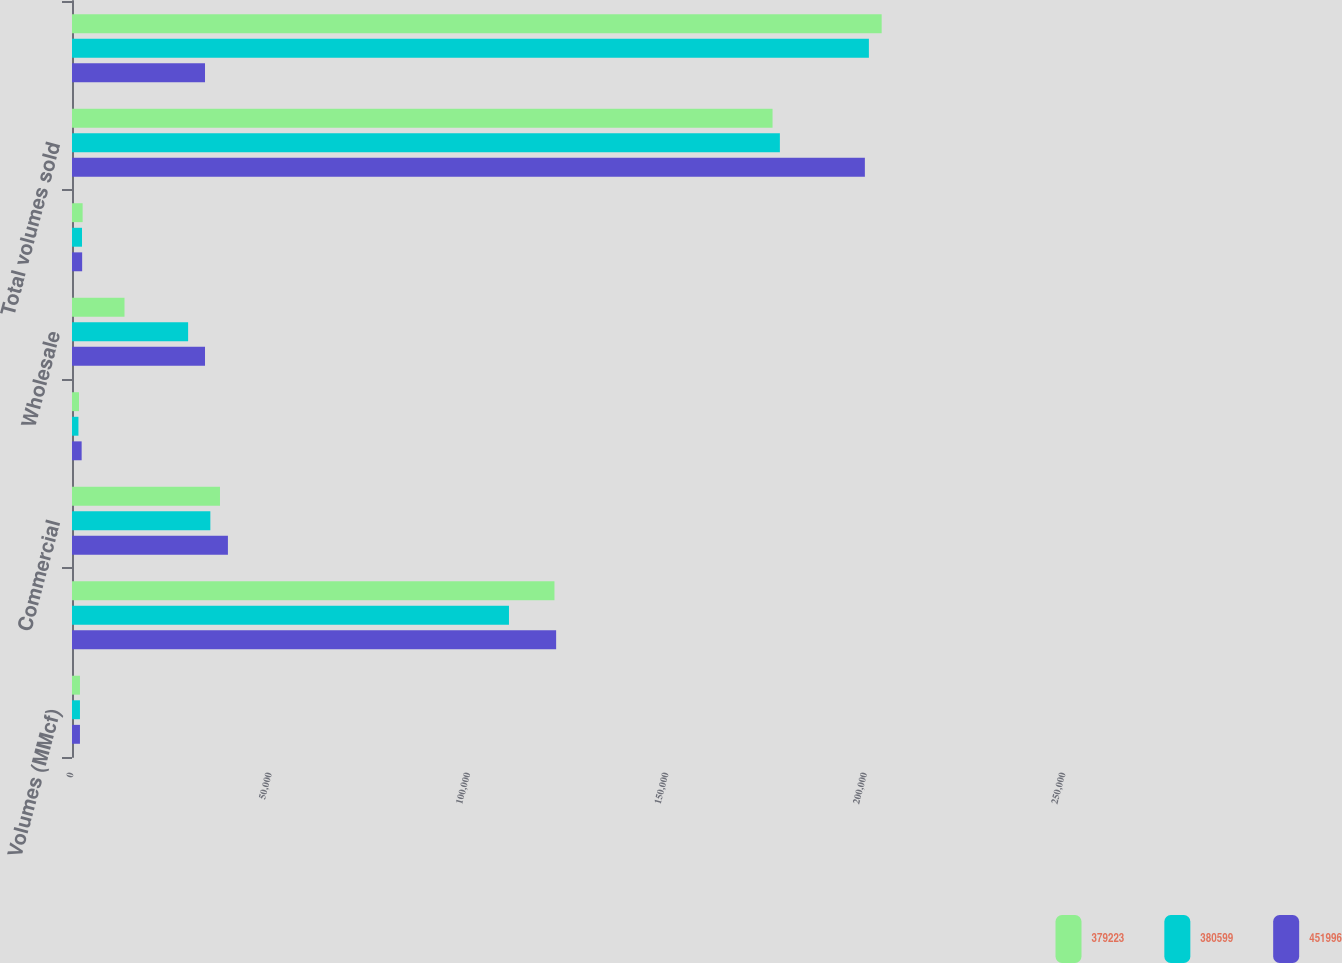<chart> <loc_0><loc_0><loc_500><loc_500><stacked_bar_chart><ecel><fcel>Volumes (MMcf)<fcel>Residential<fcel>Commercial<fcel>Industrial<fcel>Wholesale<fcel>Public Authority<fcel>Total volumes sold<fcel>Transportation<nl><fcel>379223<fcel>2007<fcel>121587<fcel>37295<fcel>1758<fcel>13231<fcel>2679<fcel>176550<fcel>204049<nl><fcel>380599<fcel>2006<fcel>110123<fcel>34865<fcel>1624<fcel>29263<fcel>2520<fcel>178395<fcel>200828<nl><fcel>451996<fcel>2005<fcel>122010<fcel>39294<fcel>2432<fcel>33521<fcel>2559<fcel>199816<fcel>33521<nl></chart> 